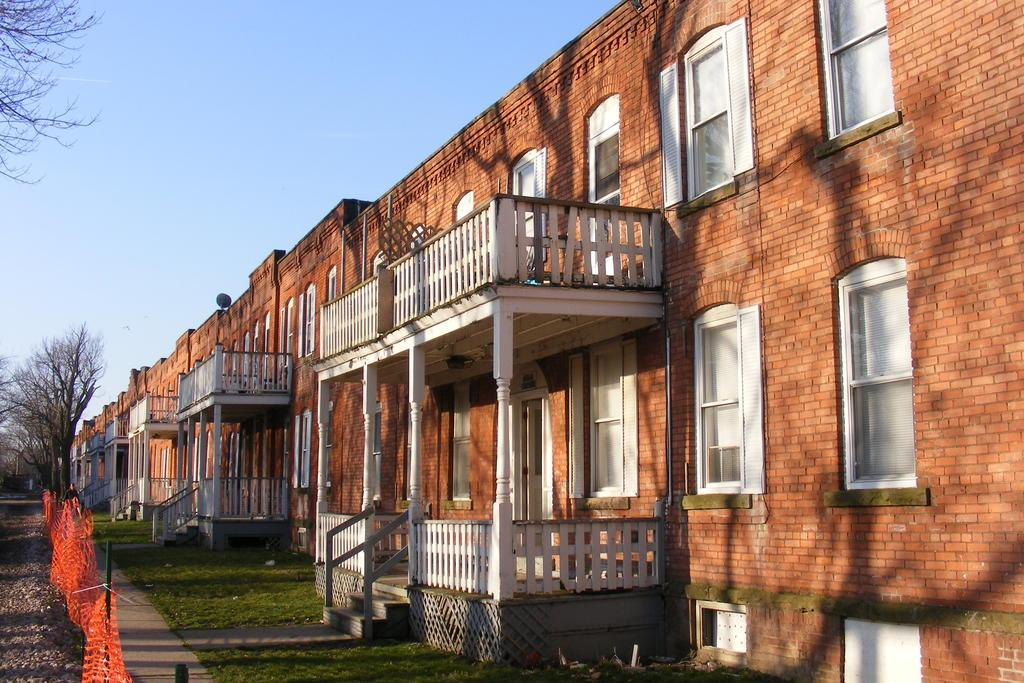What type of buildings can be seen in the image? There are brick buildings in the image. What is the barrier surrounding the area in the image? There is a fence in the image. What type of vegetation is present in the image? There is grass and trees in the image. What can be seen in the background of the image? The sky is visible in the background of the image. Can you see a bit of the map in the image? There is no map present in the image. What type of tail is visible on the tree in the image? There are no tails present in the image, as trees do not have tails. 